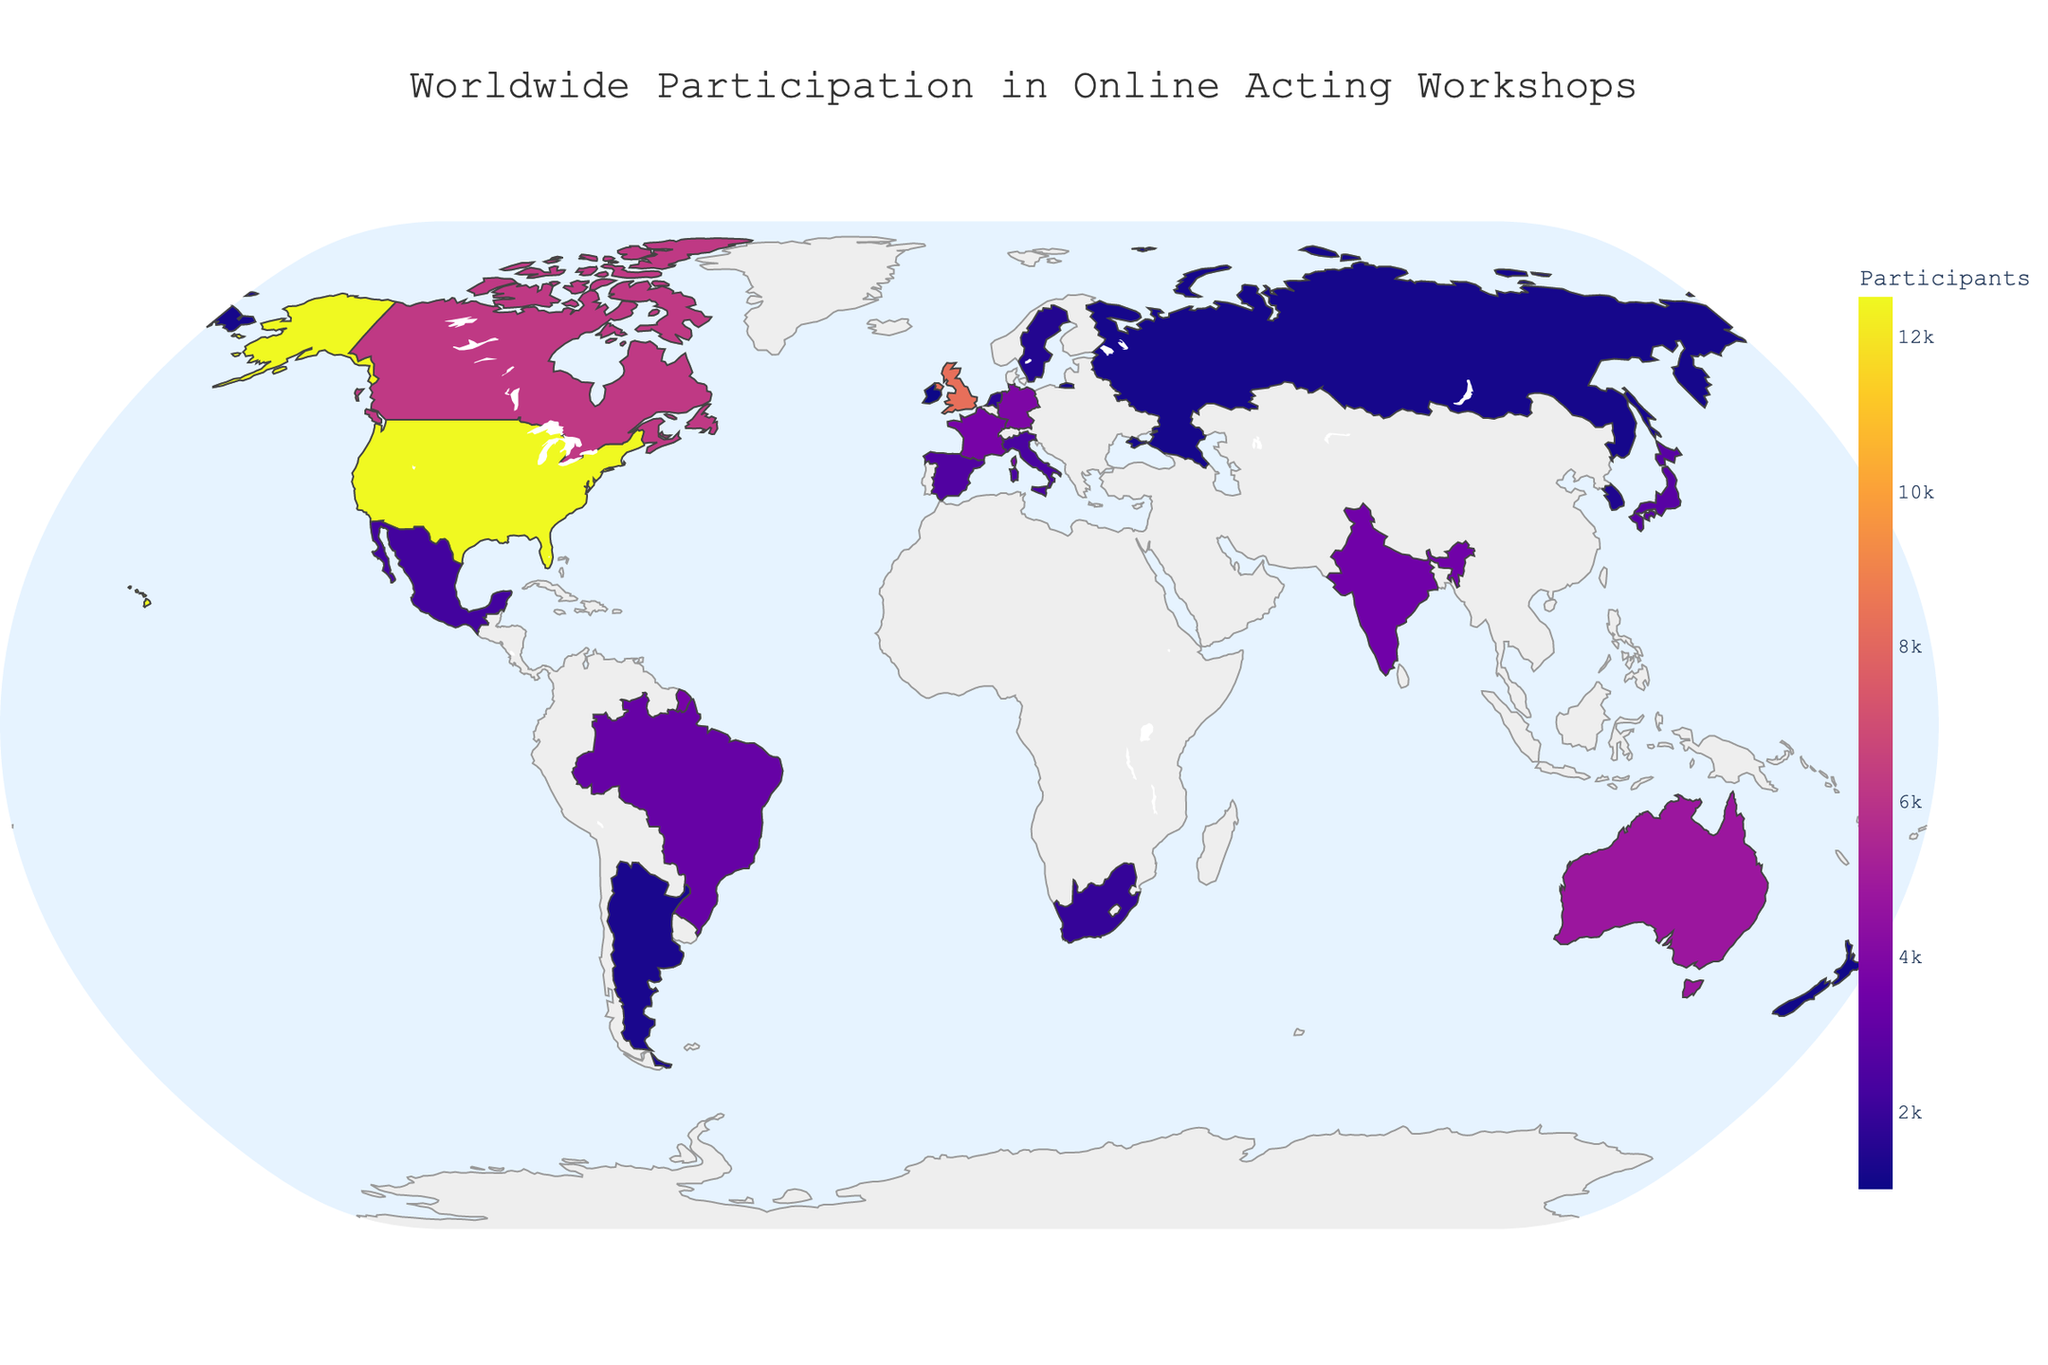What is the title of the plot? The title is positioned at the top center of the plot. It summarizes what the visual data represents.
Answer: Worldwide Participation in Online Acting Workshops Which region has the highest participation in online acting workshops? By observing the color intensity and checking the hover data for different regions, North America appears the most intense in color, indicating the highest numbers.
Answer: North America What is the total number of participants from Asian countries? Sum the participants from India, Japan, and South Korea. India: 3500, Japan: 2800, South Korea: 1400. 3500 + 2800 + 1400 = 7700
Answer: 7700 Which country in the Europe region has the highest number of participants? Based on color intensity and hover data, the United Kingdom has the highest number of participants in Europe.
Answer: United Kingdom How does the participation from Brazil compare to that of Japan? Brazil has 3200 participants, and Japan has 2800 participants. Compare these two numbers directly.
Answer: Brazil has more participants than Japan What are the top three countries in terms of participation in online acting workshops? Referencing the hover data for participant numbers, the top three are the United States (12500), the United Kingdom (8300), and Canada (6200).
Answer: United States, United Kingdom, Canada Which region contributes the least to the total number of participants? Observing the color intensity and hover data suggests Africa as the region with the least participation, given that South Africa is the only country listed and it has 1900 participants.
Answer: Africa What is the average number of participants from the countries in Oceania? Sum the participants from Australia (4800) and New Zealand (1100). Then divide by 2. (4800 + 1100) / 2 = 2950
Answer: 2950 How many countries from Europe are shown on the plot? By counting the countries listed under the "Europe" region: United Kingdom, Germany, France, Spain, Italy, Netherlands, Sweden, Russia, and Ireland.
Answer: 9 What is the difference in participants between the United States and Canada? Subtract the number of participants in Canada (6200) from those in the United States (12500). 12500 - 6200 = 6300
Answer: 6300 